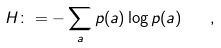Convert formula to latex. <formula><loc_0><loc_0><loc_500><loc_500>H \colon = - \sum _ { a } p ( a ) \log p ( a ) \quad ,</formula> 